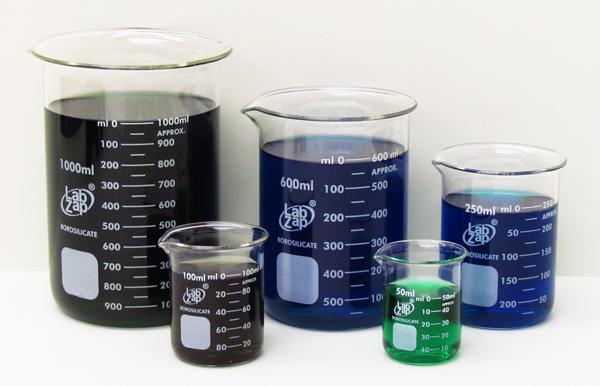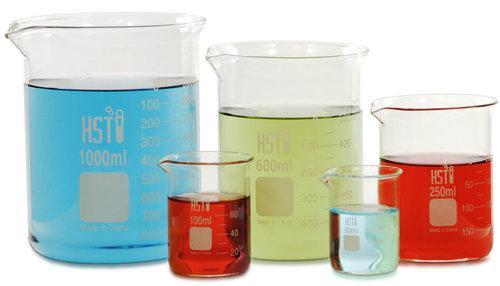The first image is the image on the left, the second image is the image on the right. Evaluate the accuracy of this statement regarding the images: "There are two beakers with red liquid in them.". Is it true? Answer yes or no. Yes. The first image is the image on the left, the second image is the image on the right. For the images displayed, is the sentence "Each image shows a group of overlapping beakers, all containing colored liquid." factually correct? Answer yes or no. Yes. The first image is the image on the left, the second image is the image on the right. Given the left and right images, does the statement "There are three beakers on the left, filled with red, blue, and green liquid." hold true? Answer yes or no. No. The first image is the image on the left, the second image is the image on the right. Assess this claim about the two images: "Two beakers contain red liquid.". Correct or not? Answer yes or no. Yes. 